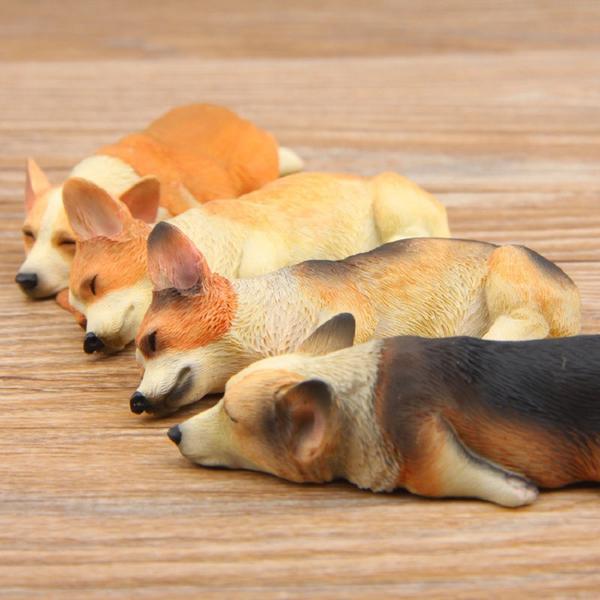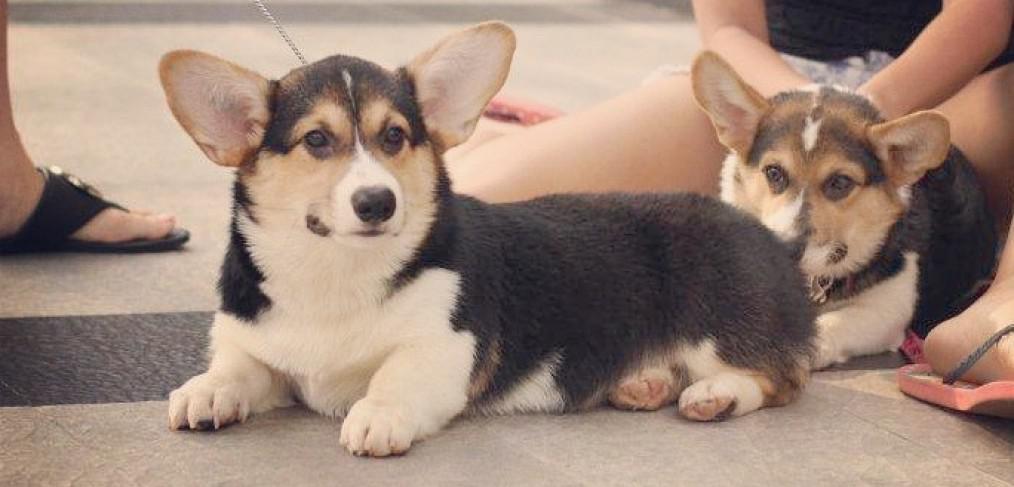The first image is the image on the left, the second image is the image on the right. Analyze the images presented: Is the assertion "There are exactly two dogs." valid? Answer yes or no. No. The first image is the image on the left, the second image is the image on the right. Analyze the images presented: Is the assertion "One image shows dogs asleep and the other image shows dogs awake." valid? Answer yes or no. Yes. 